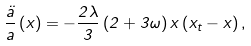Convert formula to latex. <formula><loc_0><loc_0><loc_500><loc_500>\frac { \ddot { a } } { a } \left ( x \right ) = - \frac { 2 \lambda } { 3 } \left ( 2 + 3 \omega \right ) x \left ( x _ { t } - x \right ) ,</formula> 